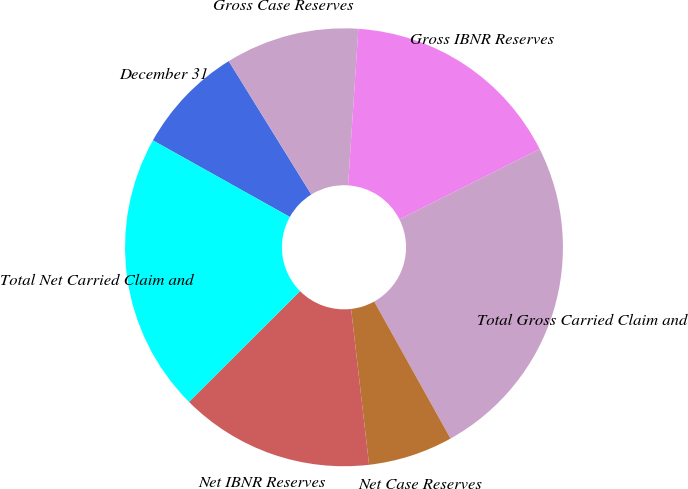Convert chart. <chart><loc_0><loc_0><loc_500><loc_500><pie_chart><fcel>December 31<fcel>Gross Case Reserves<fcel>Gross IBNR Reserves<fcel>Total Gross Carried Claim and<fcel>Net Case Reserves<fcel>Net IBNR Reserves<fcel>Total Net Carried Claim and<nl><fcel>8.06%<fcel>9.87%<fcel>16.56%<fcel>24.31%<fcel>6.26%<fcel>14.35%<fcel>20.6%<nl></chart> 